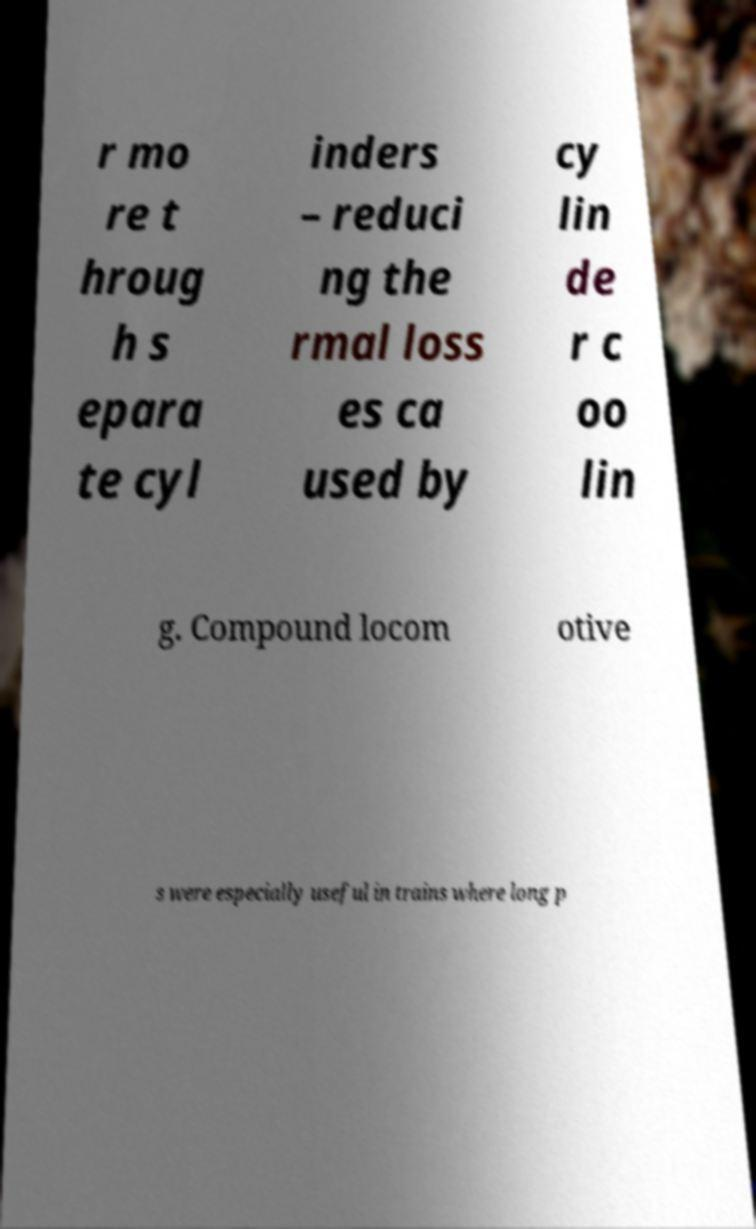What messages or text are displayed in this image? I need them in a readable, typed format. r mo re t hroug h s epara te cyl inders – reduci ng the rmal loss es ca used by cy lin de r c oo lin g. Compound locom otive s were especially useful in trains where long p 